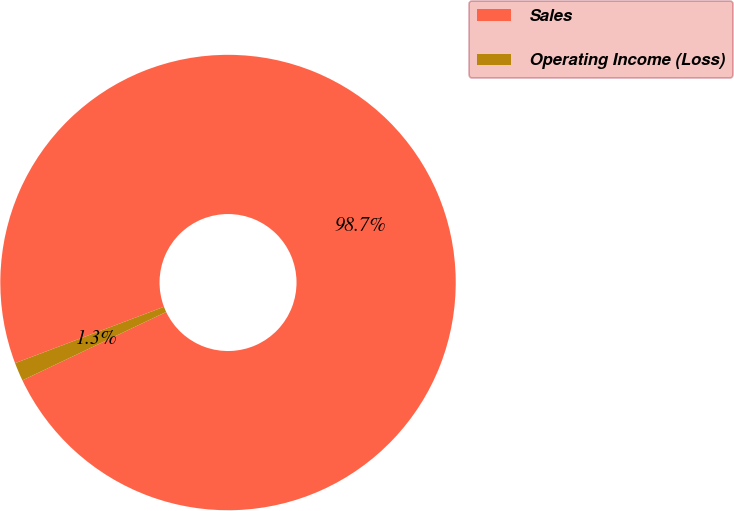Convert chart. <chart><loc_0><loc_0><loc_500><loc_500><pie_chart><fcel>Sales<fcel>Operating Income (Loss)<nl><fcel>98.69%<fcel>1.31%<nl></chart> 